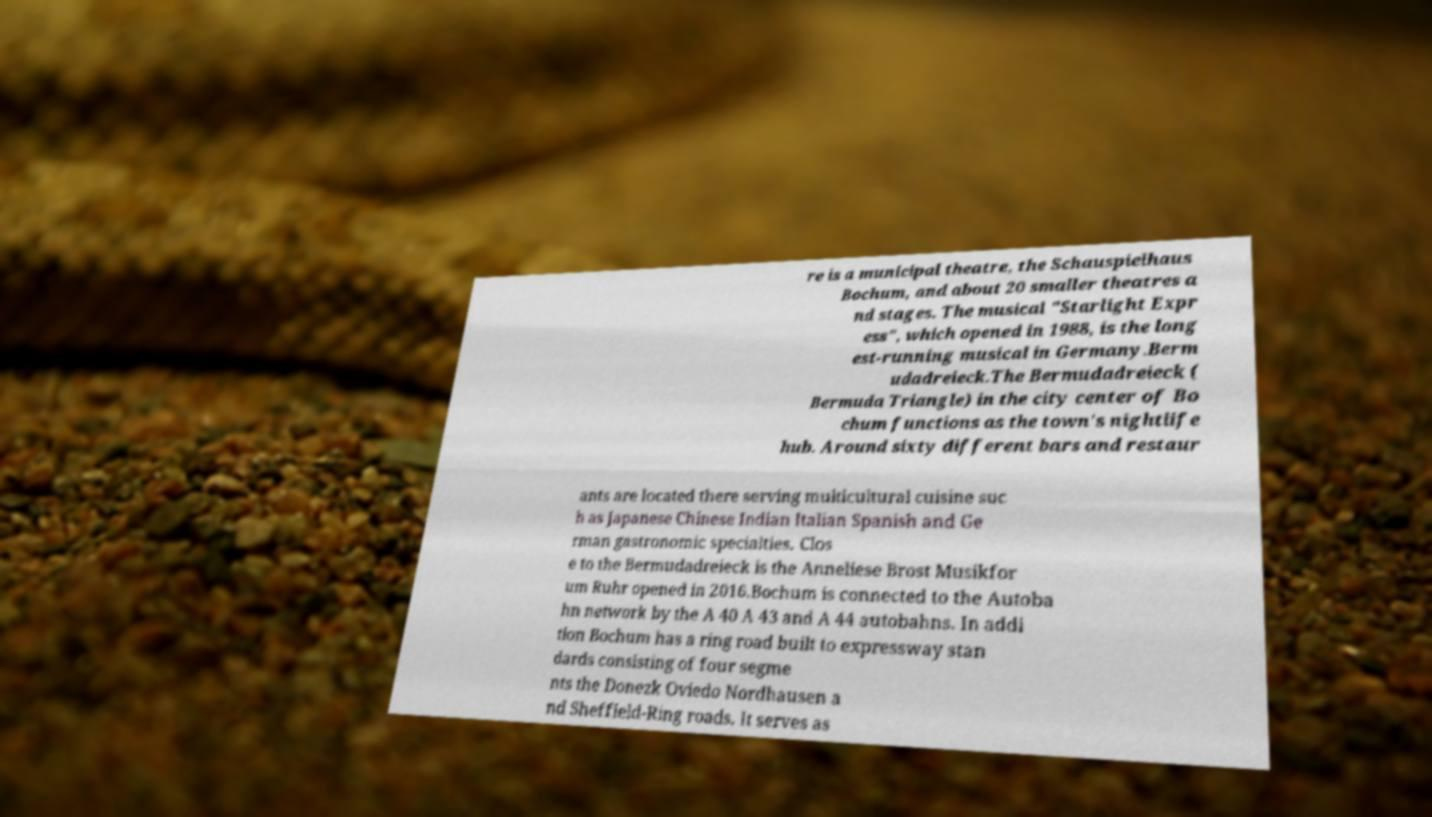Could you assist in decoding the text presented in this image and type it out clearly? re is a municipal theatre, the Schauspielhaus Bochum, and about 20 smaller theatres a nd stages. The musical "Starlight Expr ess", which opened in 1988, is the long est-running musical in Germany.Berm udadreieck.The Bermudadreieck ( Bermuda Triangle) in the city center of Bo chum functions as the town's nightlife hub. Around sixty different bars and restaur ants are located there serving multicultural cuisine suc h as Japanese Chinese Indian Italian Spanish and Ge rman gastronomic specialties. Clos e to the Bermudadreieck is the Anneliese Brost Musikfor um Ruhr opened in 2016.Bochum is connected to the Autoba hn network by the A 40 A 43 and A 44 autobahns. In addi tion Bochum has a ring road built to expressway stan dards consisting of four segme nts the Donezk Oviedo Nordhausen a nd Sheffield-Ring roads. It serves as 